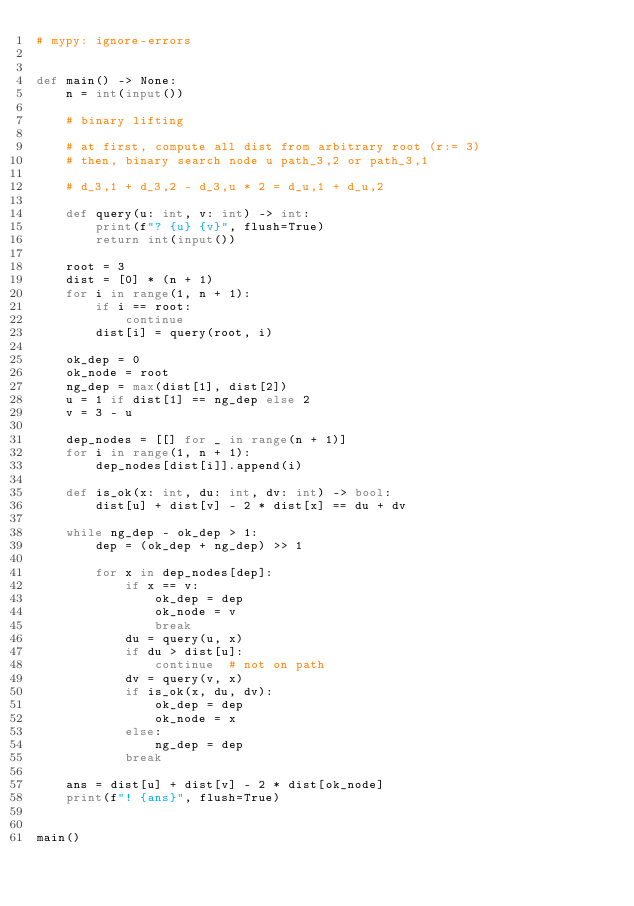<code> <loc_0><loc_0><loc_500><loc_500><_Python_># mypy: ignore-errors


def main() -> None:
    n = int(input())

    # binary lifting

    # at first, compute all dist from arbitrary root (r:= 3)
    # then, binary search node u path_3,2 or path_3,1

    # d_3,1 + d_3,2 - d_3,u * 2 = d_u,1 + d_u,2

    def query(u: int, v: int) -> int:
        print(f"? {u} {v}", flush=True)
        return int(input())

    root = 3
    dist = [0] * (n + 1)
    for i in range(1, n + 1):
        if i == root:
            continue
        dist[i] = query(root, i)

    ok_dep = 0
    ok_node = root
    ng_dep = max(dist[1], dist[2])
    u = 1 if dist[1] == ng_dep else 2
    v = 3 - u

    dep_nodes = [[] for _ in range(n + 1)]
    for i in range(1, n + 1):
        dep_nodes[dist[i]].append(i)

    def is_ok(x: int, du: int, dv: int) -> bool:
        dist[u] + dist[v] - 2 * dist[x] == du + dv

    while ng_dep - ok_dep > 1:
        dep = (ok_dep + ng_dep) >> 1

        for x in dep_nodes[dep]:
            if x == v:
                ok_dep = dep
                ok_node = v
                break
            du = query(u, x)
            if du > dist[u]:
                continue  # not on path
            dv = query(v, x)
            if is_ok(x, du, dv):
                ok_dep = dep
                ok_node = x
            else:
                ng_dep = dep
            break

    ans = dist[u] + dist[v] - 2 * dist[ok_node]
    print(f"! {ans}", flush=True)


main()
</code> 